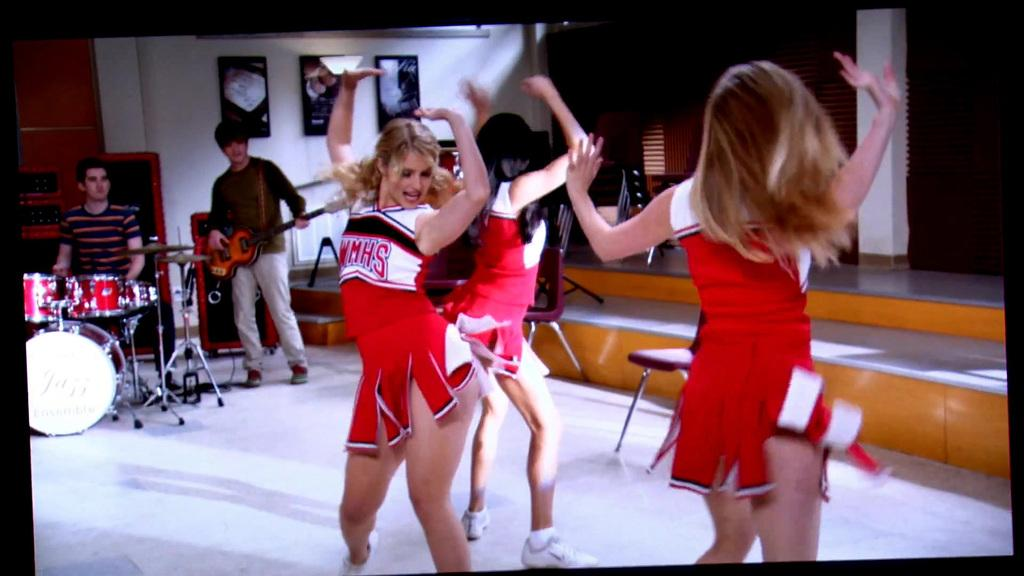<image>
Describe the image concisely. A cheerleader is wearing a red uniform that says "WMHS." 